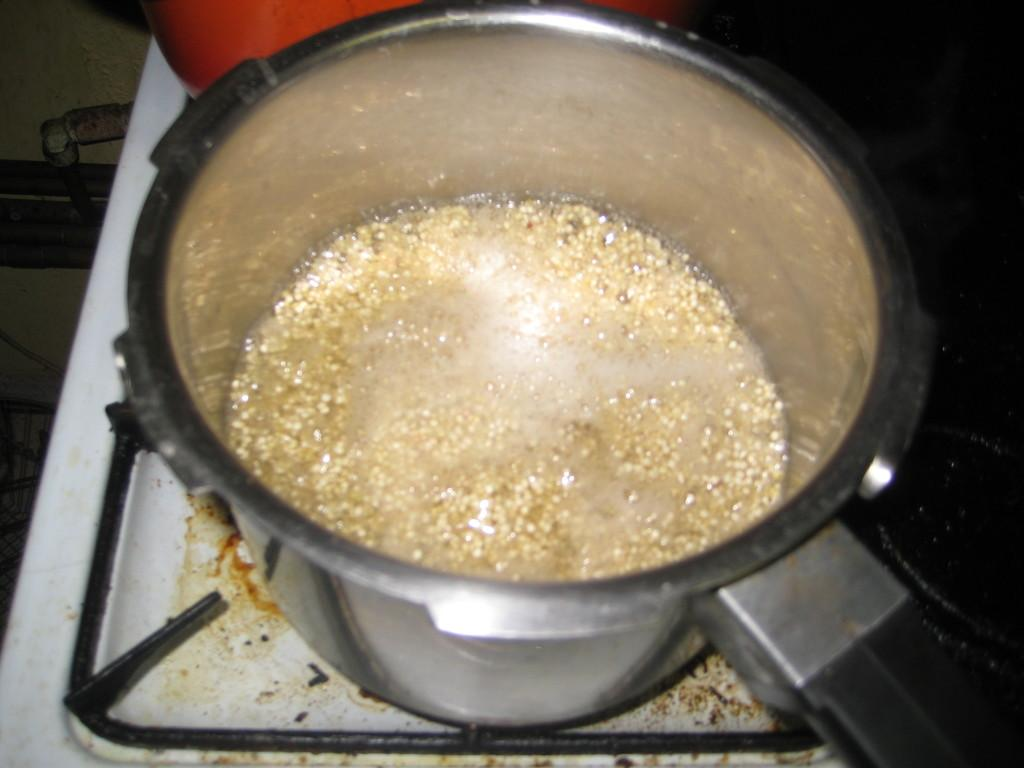What is the main subject of the image? The main subject of the image is a bowl on a stove. What is inside the bowl? The bowl contains food. Can you describe any other objects visible in the image? There are objects visible in the image, but their specific details are not mentioned in the provided facts. What is the color of the background in the image? The background of the image is dark. What type of insurance policy is being discussed in the image? There is no mention of insurance or any discussion in the image; it features a bowl on a stove with food inside. Can you see a river in the background of the image? There is no river visible in the image; the background is dark. 